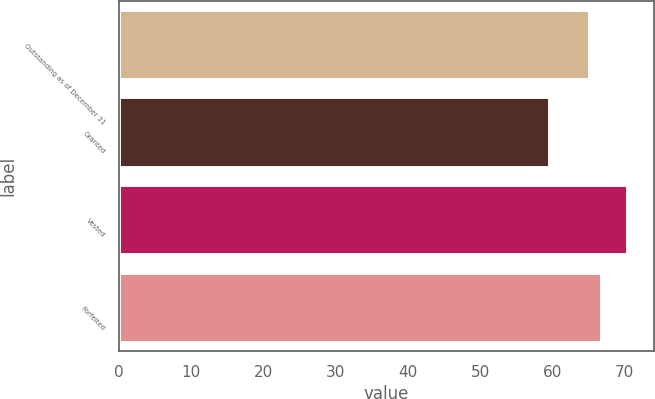Convert chart to OTSL. <chart><loc_0><loc_0><loc_500><loc_500><bar_chart><fcel>Outstanding as of December 31<fcel>Granted<fcel>Vested<fcel>Forfeited<nl><fcel>65.24<fcel>59.73<fcel>70.5<fcel>66.9<nl></chart> 